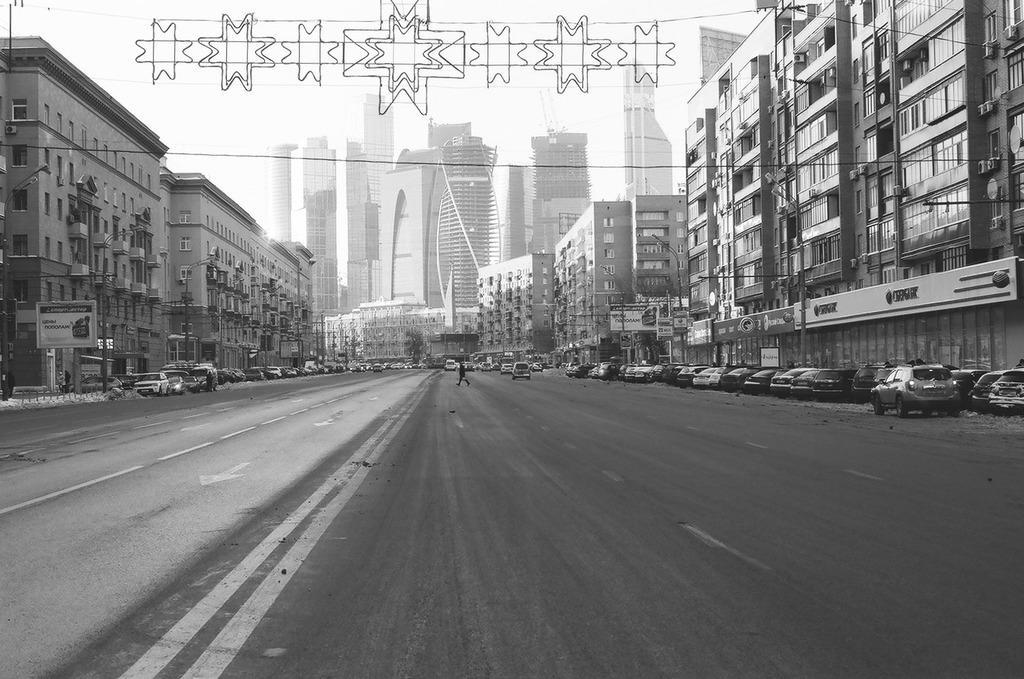In one or two sentences, can you explain what this image depicts? This picture is clicked outside. In the foreground we can see the road and the vehicles seems to be parked on the road and there is a person walking on the ground. In the background we can see the cables, sky buildings and skyscrapers. 